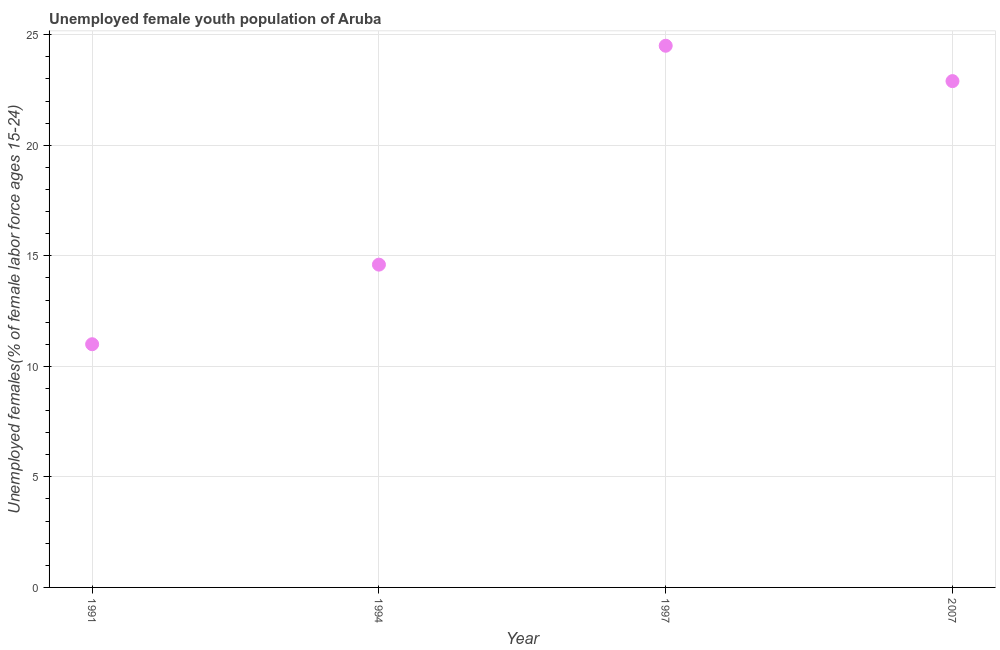Across all years, what is the maximum unemployed female youth?
Give a very brief answer. 24.5. What is the sum of the unemployed female youth?
Make the answer very short. 73. What is the difference between the unemployed female youth in 1994 and 2007?
Give a very brief answer. -8.3. What is the average unemployed female youth per year?
Your response must be concise. 18.25. What is the median unemployed female youth?
Your answer should be compact. 18.75. What is the ratio of the unemployed female youth in 1991 to that in 1994?
Provide a short and direct response. 0.75. Is the unemployed female youth in 1994 less than that in 2007?
Keep it short and to the point. Yes. Is the difference between the unemployed female youth in 1994 and 1997 greater than the difference between any two years?
Provide a succinct answer. No. What is the difference between the highest and the second highest unemployed female youth?
Give a very brief answer. 1.6. What is the difference between the highest and the lowest unemployed female youth?
Ensure brevity in your answer.  13.5. Does the unemployed female youth monotonically increase over the years?
Give a very brief answer. No. How many dotlines are there?
Give a very brief answer. 1. What is the difference between two consecutive major ticks on the Y-axis?
Your answer should be very brief. 5. Are the values on the major ticks of Y-axis written in scientific E-notation?
Ensure brevity in your answer.  No. Does the graph contain any zero values?
Ensure brevity in your answer.  No. Does the graph contain grids?
Give a very brief answer. Yes. What is the title of the graph?
Provide a short and direct response. Unemployed female youth population of Aruba. What is the label or title of the Y-axis?
Ensure brevity in your answer.  Unemployed females(% of female labor force ages 15-24). What is the Unemployed females(% of female labor force ages 15-24) in 1991?
Offer a very short reply. 11. What is the Unemployed females(% of female labor force ages 15-24) in 1994?
Ensure brevity in your answer.  14.6. What is the Unemployed females(% of female labor force ages 15-24) in 1997?
Your answer should be compact. 24.5. What is the Unemployed females(% of female labor force ages 15-24) in 2007?
Offer a very short reply. 22.9. What is the difference between the Unemployed females(% of female labor force ages 15-24) in 1991 and 2007?
Offer a very short reply. -11.9. What is the difference between the Unemployed females(% of female labor force ages 15-24) in 1994 and 2007?
Give a very brief answer. -8.3. What is the difference between the Unemployed females(% of female labor force ages 15-24) in 1997 and 2007?
Ensure brevity in your answer.  1.6. What is the ratio of the Unemployed females(% of female labor force ages 15-24) in 1991 to that in 1994?
Your response must be concise. 0.75. What is the ratio of the Unemployed females(% of female labor force ages 15-24) in 1991 to that in 1997?
Offer a very short reply. 0.45. What is the ratio of the Unemployed females(% of female labor force ages 15-24) in 1991 to that in 2007?
Your response must be concise. 0.48. What is the ratio of the Unemployed females(% of female labor force ages 15-24) in 1994 to that in 1997?
Provide a short and direct response. 0.6. What is the ratio of the Unemployed females(% of female labor force ages 15-24) in 1994 to that in 2007?
Make the answer very short. 0.64. What is the ratio of the Unemployed females(% of female labor force ages 15-24) in 1997 to that in 2007?
Provide a succinct answer. 1.07. 